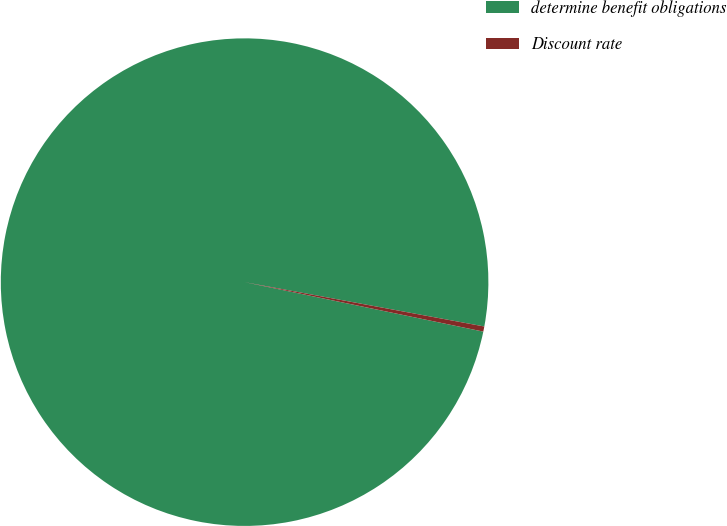Convert chart to OTSL. <chart><loc_0><loc_0><loc_500><loc_500><pie_chart><fcel>determine benefit obligations<fcel>Discount rate<nl><fcel>99.66%<fcel>0.34%<nl></chart> 